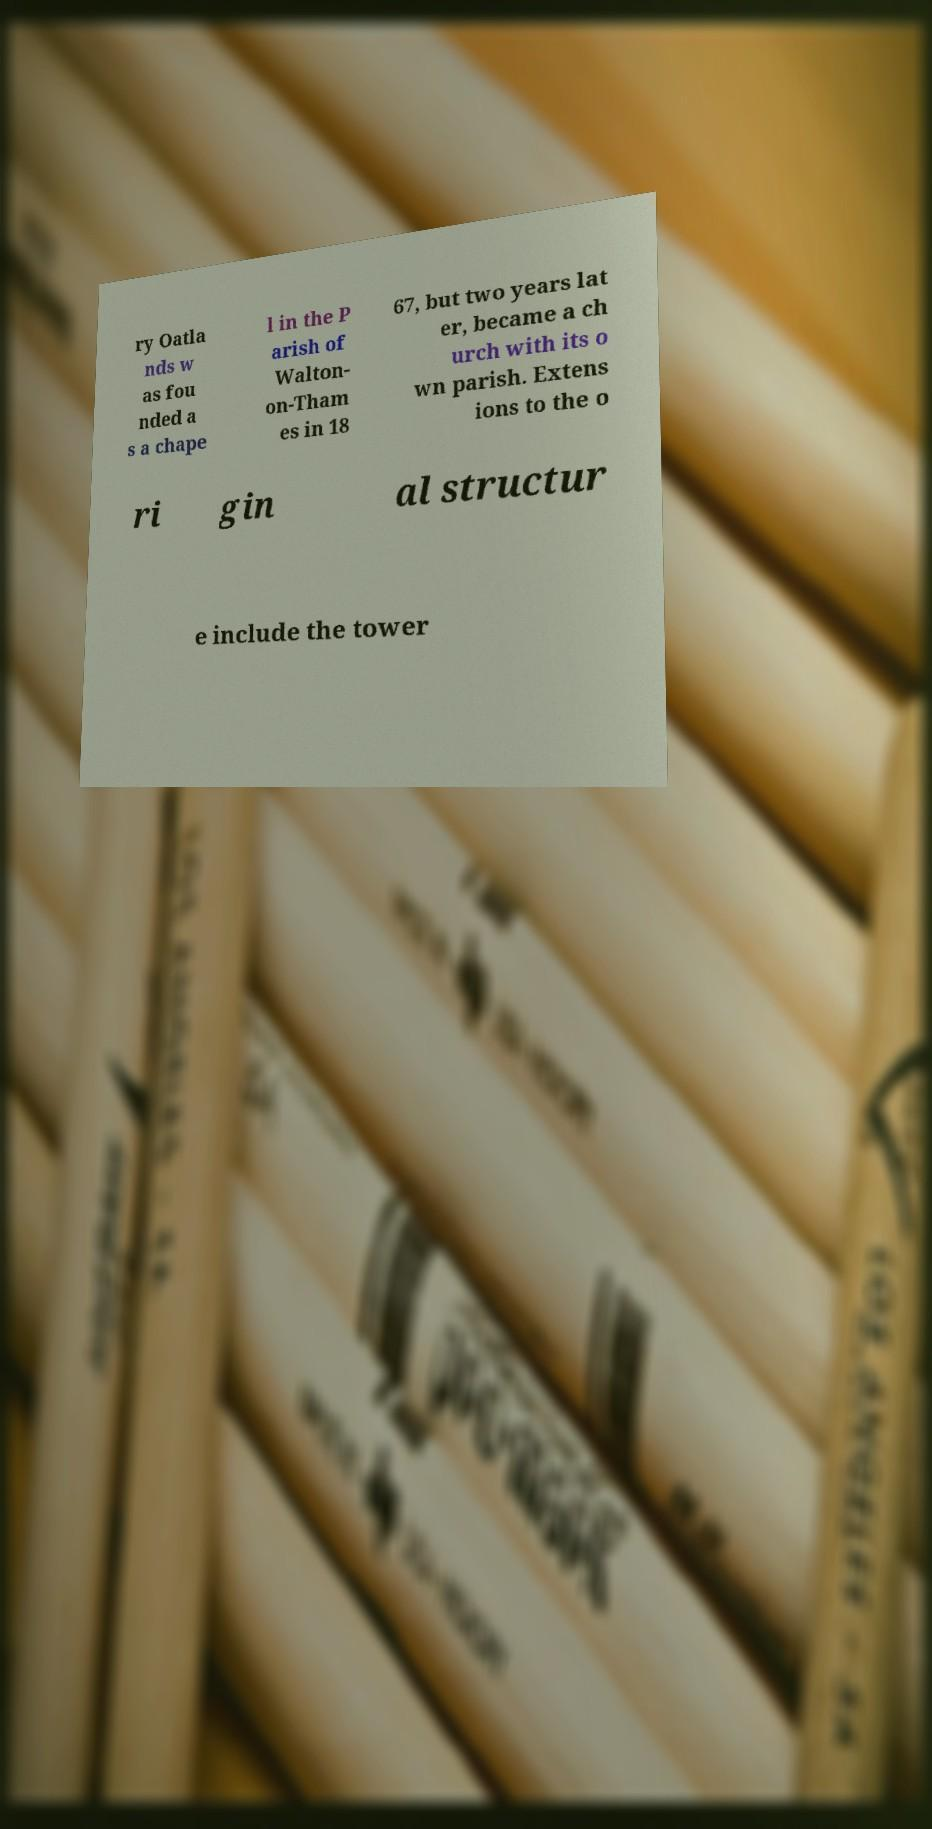Could you assist in decoding the text presented in this image and type it out clearly? ry Oatla nds w as fou nded a s a chape l in the P arish of Walton- on-Tham es in 18 67, but two years lat er, became a ch urch with its o wn parish. Extens ions to the o ri gin al structur e include the tower 